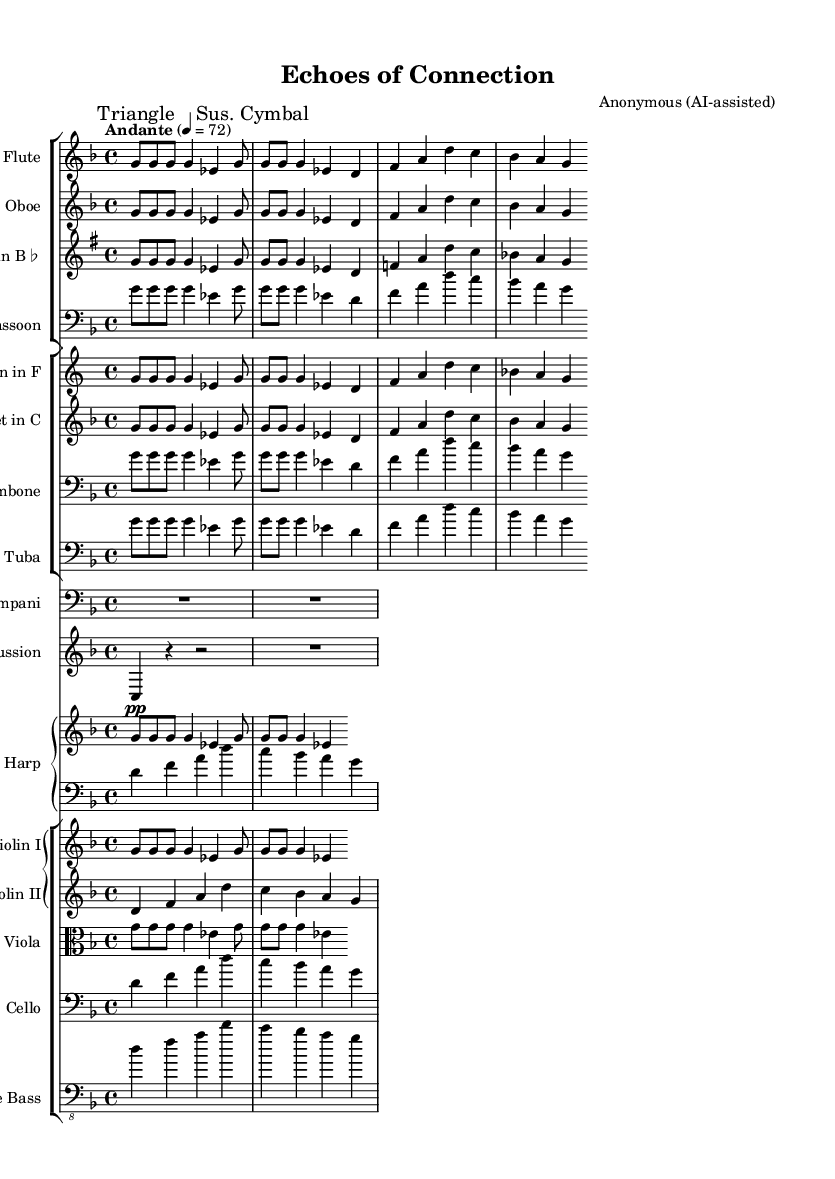What is the key signature of this music? The key signature appears at the beginning of the staff and indicates D minor, which has one flat (B♭).
Answer: D minor What is the time signature of this music? The time signature is indicated by two numbers at the beginning of the sheet, showing that there are four beats in a measure and the quarter note receives one beat, represented as 4/4.
Answer: 4/4 What is the tempo marking for this piece? The tempo marking is placed at the top of the sheet and specifies "Andante," indicating a moderate pace, with a specific speed of 72 beats per minute.
Answer: Andante How many instruments are featured in this symphonic work? By counting all the distinct staves for each instrument in the score, we find there are 12 different instruments indicated.
Answer: 12 Which section of the orchestra is represented by the bassoon? Looking at the instruments grouped in the score, the bassoon is categorized under the woodwind instruments, which are typically found in the woodwind section.
Answer: Woodwind What type of musical passage is indicated by "R1*2" for the Timpani? This notation indicates a measure of rest for the timpani, meaning the player does not play for the duration of two beats.
Answer: Rest Which instruments play the human voice part? The human voice part is written for multiple instruments, specifically seen in the Flute, Oboe, Violin II, Cello, and Double Bass.
Answer: Flute, Oboe, Violin II, Cello, Double Bass 